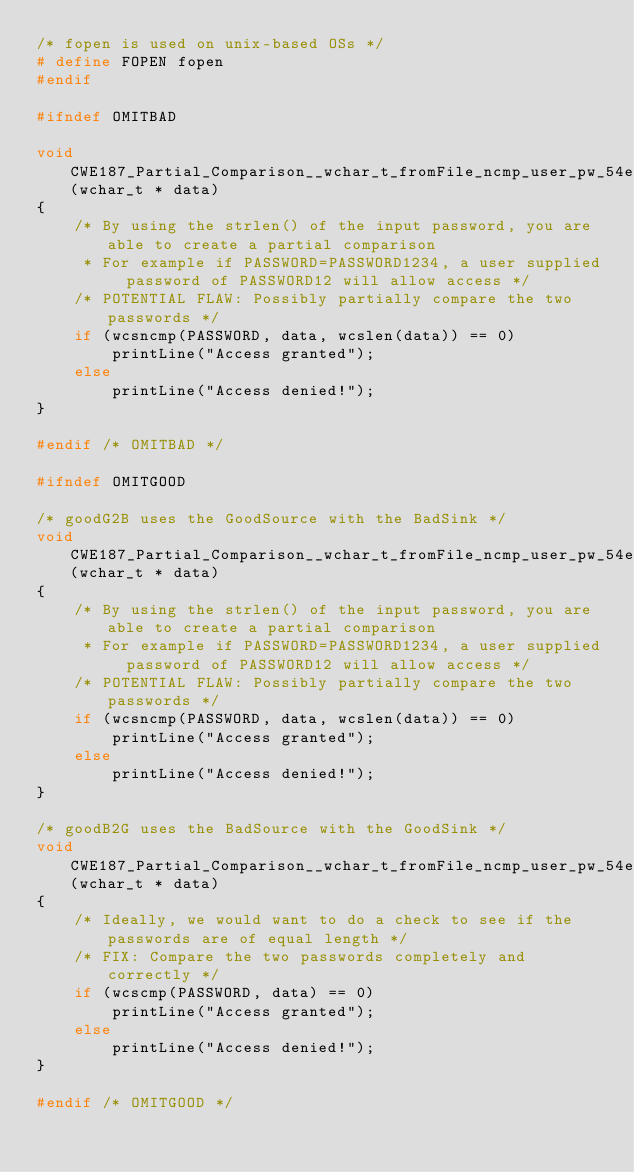<code> <loc_0><loc_0><loc_500><loc_500><_C_>/* fopen is used on unix-based OSs */
# define FOPEN fopen
#endif

#ifndef OMITBAD

void CWE187_Partial_Comparison__wchar_t_fromFile_ncmp_user_pw_54e_bad_sink(wchar_t * data)
{
    /* By using the strlen() of the input password, you are able to create a partial comparison
     * For example if PASSWORD=PASSWORD1234, a user supplied password of PASSWORD12 will allow access */
    /* POTENTIAL FLAW: Possibly partially compare the two passwords */
    if (wcsncmp(PASSWORD, data, wcslen(data)) == 0)
        printLine("Access granted");
    else
        printLine("Access denied!");
}

#endif /* OMITBAD */

#ifndef OMITGOOD

/* goodG2B uses the GoodSource with the BadSink */
void CWE187_Partial_Comparison__wchar_t_fromFile_ncmp_user_pw_54e_goodG2B_sink(wchar_t * data)
{
    /* By using the strlen() of the input password, you are able to create a partial comparison
     * For example if PASSWORD=PASSWORD1234, a user supplied password of PASSWORD12 will allow access */
    /* POTENTIAL FLAW: Possibly partially compare the two passwords */
    if (wcsncmp(PASSWORD, data, wcslen(data)) == 0)
        printLine("Access granted");
    else
        printLine("Access denied!");
}

/* goodB2G uses the BadSource with the GoodSink */
void CWE187_Partial_Comparison__wchar_t_fromFile_ncmp_user_pw_54e_goodB2G_sink(wchar_t * data)
{
    /* Ideally, we would want to do a check to see if the passwords are of equal length */
    /* FIX: Compare the two passwords completely and correctly */
    if (wcscmp(PASSWORD, data) == 0)
        printLine("Access granted");
    else
        printLine("Access denied!");
}

#endif /* OMITGOOD */
</code> 